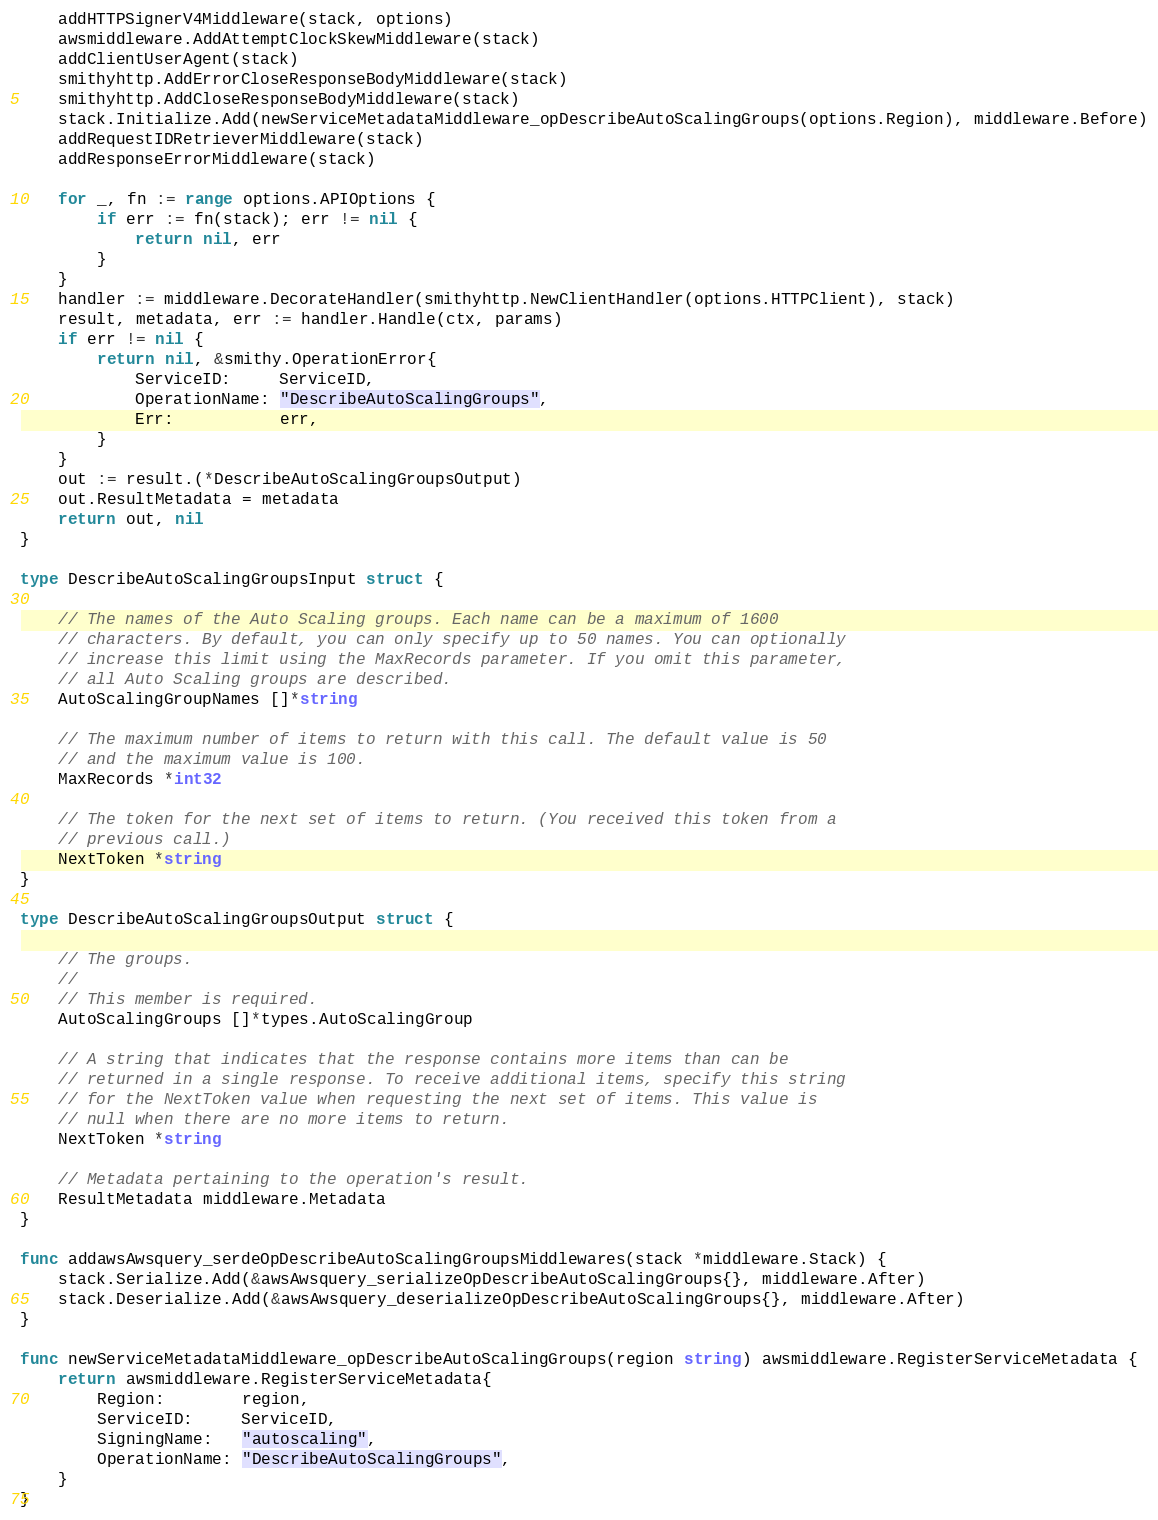Convert code to text. <code><loc_0><loc_0><loc_500><loc_500><_Go_>	addHTTPSignerV4Middleware(stack, options)
	awsmiddleware.AddAttemptClockSkewMiddleware(stack)
	addClientUserAgent(stack)
	smithyhttp.AddErrorCloseResponseBodyMiddleware(stack)
	smithyhttp.AddCloseResponseBodyMiddleware(stack)
	stack.Initialize.Add(newServiceMetadataMiddleware_opDescribeAutoScalingGroups(options.Region), middleware.Before)
	addRequestIDRetrieverMiddleware(stack)
	addResponseErrorMiddleware(stack)

	for _, fn := range options.APIOptions {
		if err := fn(stack); err != nil {
			return nil, err
		}
	}
	handler := middleware.DecorateHandler(smithyhttp.NewClientHandler(options.HTTPClient), stack)
	result, metadata, err := handler.Handle(ctx, params)
	if err != nil {
		return nil, &smithy.OperationError{
			ServiceID:     ServiceID,
			OperationName: "DescribeAutoScalingGroups",
			Err:           err,
		}
	}
	out := result.(*DescribeAutoScalingGroupsOutput)
	out.ResultMetadata = metadata
	return out, nil
}

type DescribeAutoScalingGroupsInput struct {

	// The names of the Auto Scaling groups. Each name can be a maximum of 1600
	// characters. By default, you can only specify up to 50 names. You can optionally
	// increase this limit using the MaxRecords parameter. If you omit this parameter,
	// all Auto Scaling groups are described.
	AutoScalingGroupNames []*string

	// The maximum number of items to return with this call. The default value is 50
	// and the maximum value is 100.
	MaxRecords *int32

	// The token for the next set of items to return. (You received this token from a
	// previous call.)
	NextToken *string
}

type DescribeAutoScalingGroupsOutput struct {

	// The groups.
	//
	// This member is required.
	AutoScalingGroups []*types.AutoScalingGroup

	// A string that indicates that the response contains more items than can be
	// returned in a single response. To receive additional items, specify this string
	// for the NextToken value when requesting the next set of items. This value is
	// null when there are no more items to return.
	NextToken *string

	// Metadata pertaining to the operation's result.
	ResultMetadata middleware.Metadata
}

func addawsAwsquery_serdeOpDescribeAutoScalingGroupsMiddlewares(stack *middleware.Stack) {
	stack.Serialize.Add(&awsAwsquery_serializeOpDescribeAutoScalingGroups{}, middleware.After)
	stack.Deserialize.Add(&awsAwsquery_deserializeOpDescribeAutoScalingGroups{}, middleware.After)
}

func newServiceMetadataMiddleware_opDescribeAutoScalingGroups(region string) awsmiddleware.RegisterServiceMetadata {
	return awsmiddleware.RegisterServiceMetadata{
		Region:        region,
		ServiceID:     ServiceID,
		SigningName:   "autoscaling",
		OperationName: "DescribeAutoScalingGroups",
	}
}
</code> 